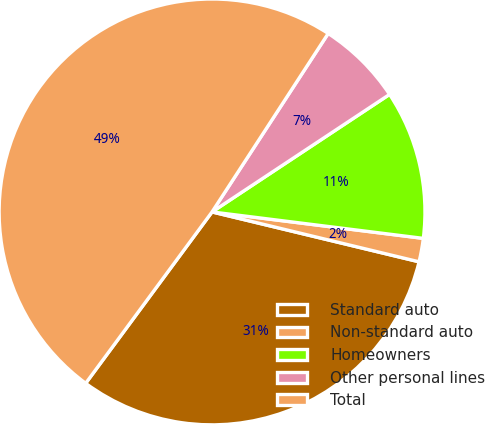Convert chart to OTSL. <chart><loc_0><loc_0><loc_500><loc_500><pie_chart><fcel>Standard auto<fcel>Non-standard auto<fcel>Homeowners<fcel>Other personal lines<fcel>Total<nl><fcel>31.35%<fcel>1.78%<fcel>11.29%<fcel>6.51%<fcel>49.07%<nl></chart> 